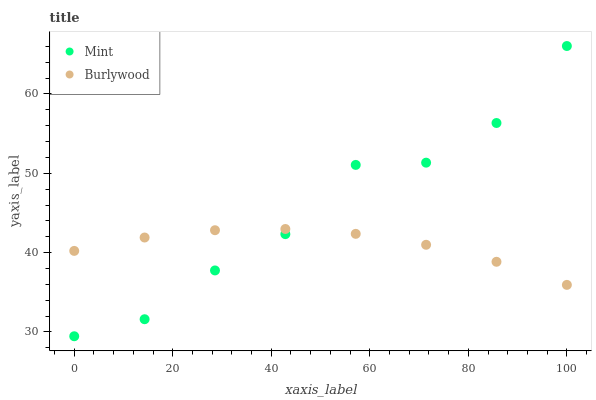Does Burlywood have the minimum area under the curve?
Answer yes or no. Yes. Does Mint have the maximum area under the curve?
Answer yes or no. Yes. Does Mint have the minimum area under the curve?
Answer yes or no. No. Is Burlywood the smoothest?
Answer yes or no. Yes. Is Mint the roughest?
Answer yes or no. Yes. Is Mint the smoothest?
Answer yes or no. No. Does Mint have the lowest value?
Answer yes or no. Yes. Does Mint have the highest value?
Answer yes or no. Yes. Does Mint intersect Burlywood?
Answer yes or no. Yes. Is Mint less than Burlywood?
Answer yes or no. No. Is Mint greater than Burlywood?
Answer yes or no. No. 